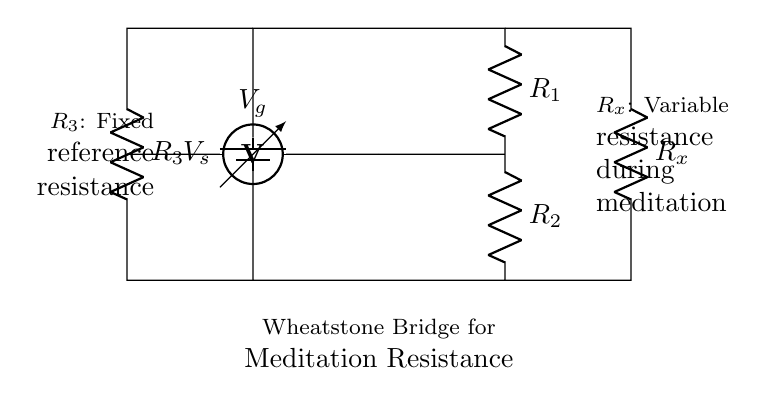What is the purpose of R_x in this circuit? R_x is the variable resistance that changes during meditation, allowing for measurements of subtle resistance changes.
Answer: variable resistance What is the role of R_3 in the Wheatstone bridge? R_3 acts as a fixed reference resistance against which R_x is compared; it helps in determining the changes in resistance when meditation occurs.
Answer: fixed reference resistance What does V_g represent in this circuit? V_g is the voltage across the galvanometer, indicating whether there is a balance in the bridge or not, based on the differences between resistances.
Answer: voltage across the galvanometer How many resistors are in the Wheatstone bridge diagram? There are four resistors in total: R_1, R_2, R_3, and R_x.
Answer: four What might happen to V_g if R_x increases significantly? If R_x increases significantly, V_g would likely become unbalanced, indicating a change in resistance that may correlate with meditation effects.
Answer: become unbalanced What are the two categories of resistors in this Wheatstone bridge? The resistors can be categorized into two types: fixed resistance (R_3) and variable resistance (R_x).
Answer: fixed and variable 